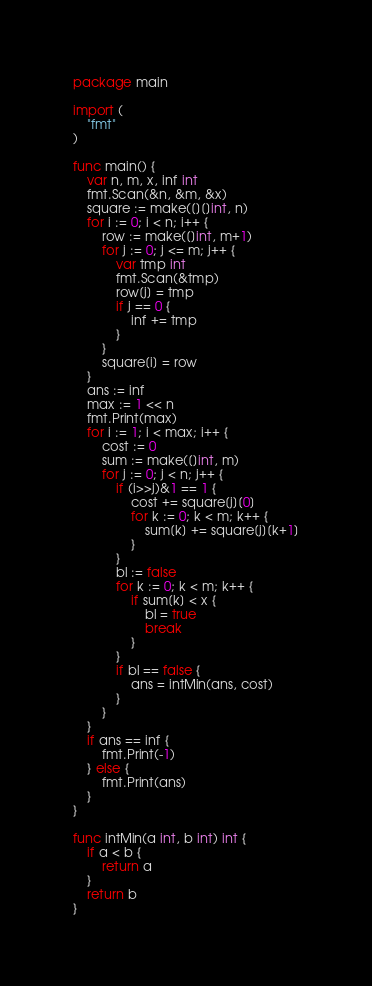Convert code to text. <code><loc_0><loc_0><loc_500><loc_500><_Go_>package main

import (
	"fmt"
)

func main() {
	var n, m, x, inf int
	fmt.Scan(&n, &m, &x)
	square := make([][]int, n)
	for i := 0; i < n; i++ {
		row := make([]int, m+1)
		for j := 0; j <= m; j++ {
			var tmp int
			fmt.Scan(&tmp)
			row[j] = tmp
			if j == 0 {
				inf += tmp
			}
		}
		square[i] = row
	}
	ans := inf
	max := 1 << n
	fmt.Print(max)
	for i := 1; i < max; i++ {
		cost := 0
		sum := make([]int, m)
		for j := 0; j < n; j++ {
			if (i>>j)&1 == 1 {
				cost += square[j][0]
				for k := 0; k < m; k++ {
					sum[k] += square[j][k+1]
				}
			}
			bl := false
			for k := 0; k < m; k++ {
				if sum[k] < x {
					bl = true
					break
				}
			}
			if bl == false {
				ans = intMin(ans, cost)
			}
		}
	}
	if ans == inf {
		fmt.Print(-1)
	} else {
		fmt.Print(ans)
	}
}

func intMin(a int, b int) int {
	if a < b {
		return a
	}
	return b
}
</code> 